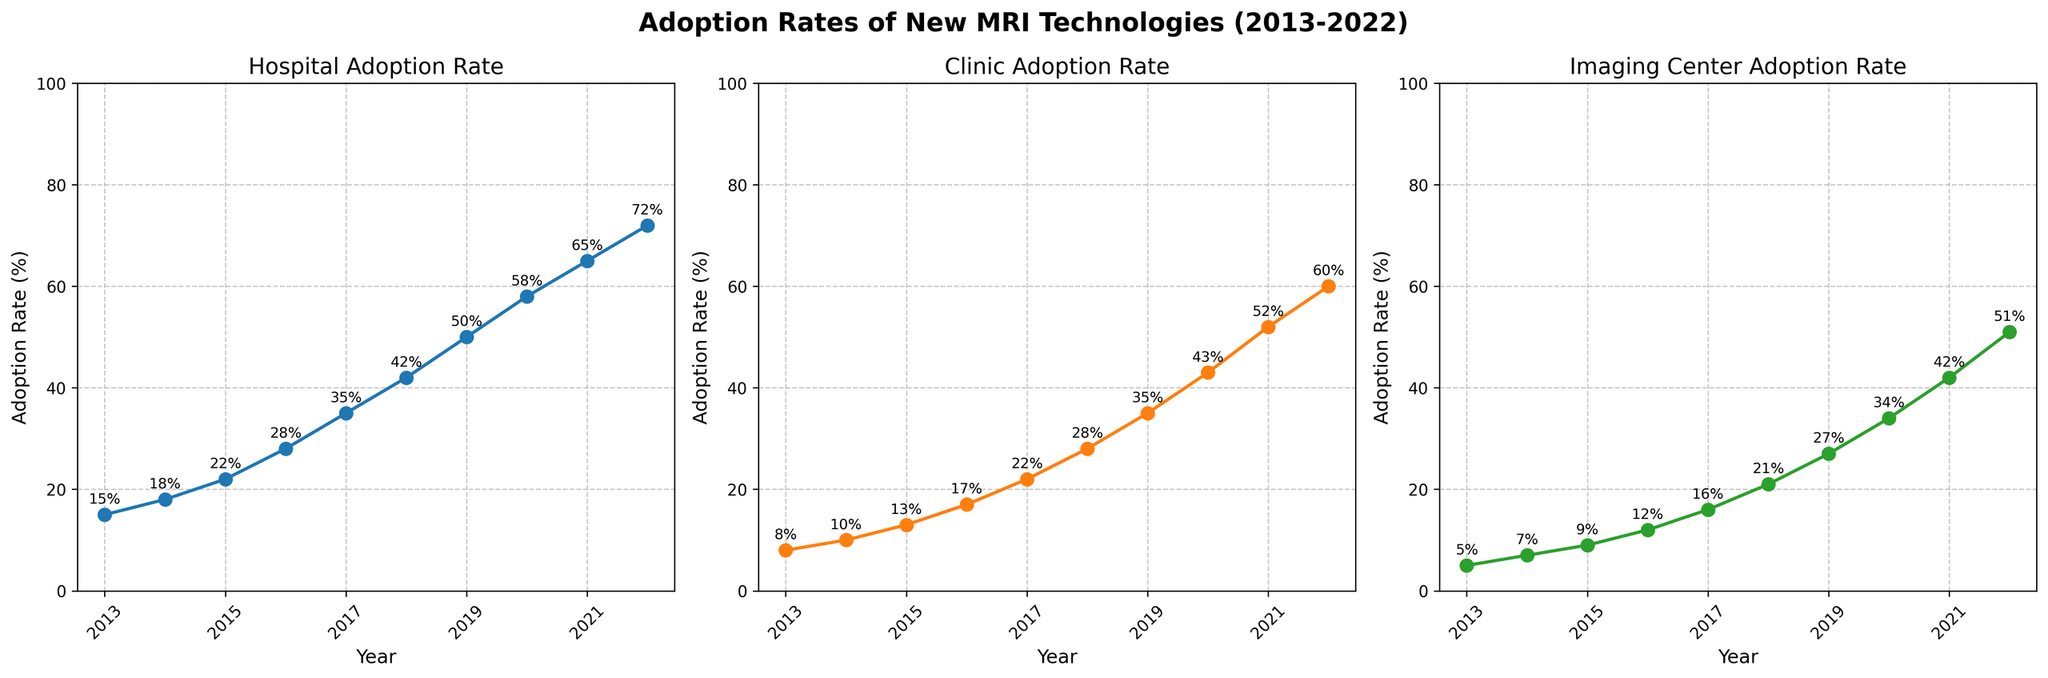how many years of data are shown in the figure? The plot starts at 2013 and ends at 2022. By counting the years from 2013 to 2022 inclusively, it spans 10 years.
Answer: 10 what’s the adoption rate for hospitals in 2018? Look at the subplot titled "Hospital Adoption Rate," find the data point for 2018 and the corresponding y-axis value.
Answer: 42% which year shows the highest adoption rate for clinics? In the subplot titled "Clinic Adoption Rate," the highest point on the line corresponds to the year 2022.
Answer: 2022 compare the adoption rates in 2015 between hospitals and imaging centers. Which one had a higher rate? In the subplots for hospitals and imaging centers, identify the rates for 2015; hospitals have a rate of 22%, while imaging centers have 9%. Compare the two values.
Answer: hospitals how much did the adoption rate for imaging centers increase from 2018 to 2019? Find the rates for imaging centers in 2018 and 2019 on the respective subplot; 2018 is 21% and 2019 is 27%. Subtract 21 from 27.
Answer: 6% what is the average annual increase in adoption rates for clinics over the decade? Find the adoption rates for clinics in 2013 (8%) and 2022 (60%). Subtract 8 from 60 to get the total increase, which is 52%. Then, divide by the number of years (10) to get the average annual increase.
Answer: 5.2% which location type shows the steepest increase in adoption rate from 2014 to 2015? Compare the year-on-year increase for each location between 2014 and 2015. Hospitals increase from 18% to 22%, clinics from 10% to 13%, and imaging centers from 7% to 9%. Calculate each increase: hospitals 4%, clinics 3%, imaging centers 2%.
Answer: hospitals based on the figure, describe the general trend in adoption rates for clinics from 2013 to 2022. The "Clinic Adoption Rate" subplot shows a consistent upward trend, indicating that the adoption of new MRI technologies in clinics has been steadily increasing over the years.
Answer: increasing in which years did the adoption rates for hospitals exceed 50%? On the "Hospital Adoption Rate" subplot, look for the data points where the value on the y-axis is greater than 50%, which occurs in the years 2020, 2021, and 2022.
Answer: 2020, 2021, 2022 